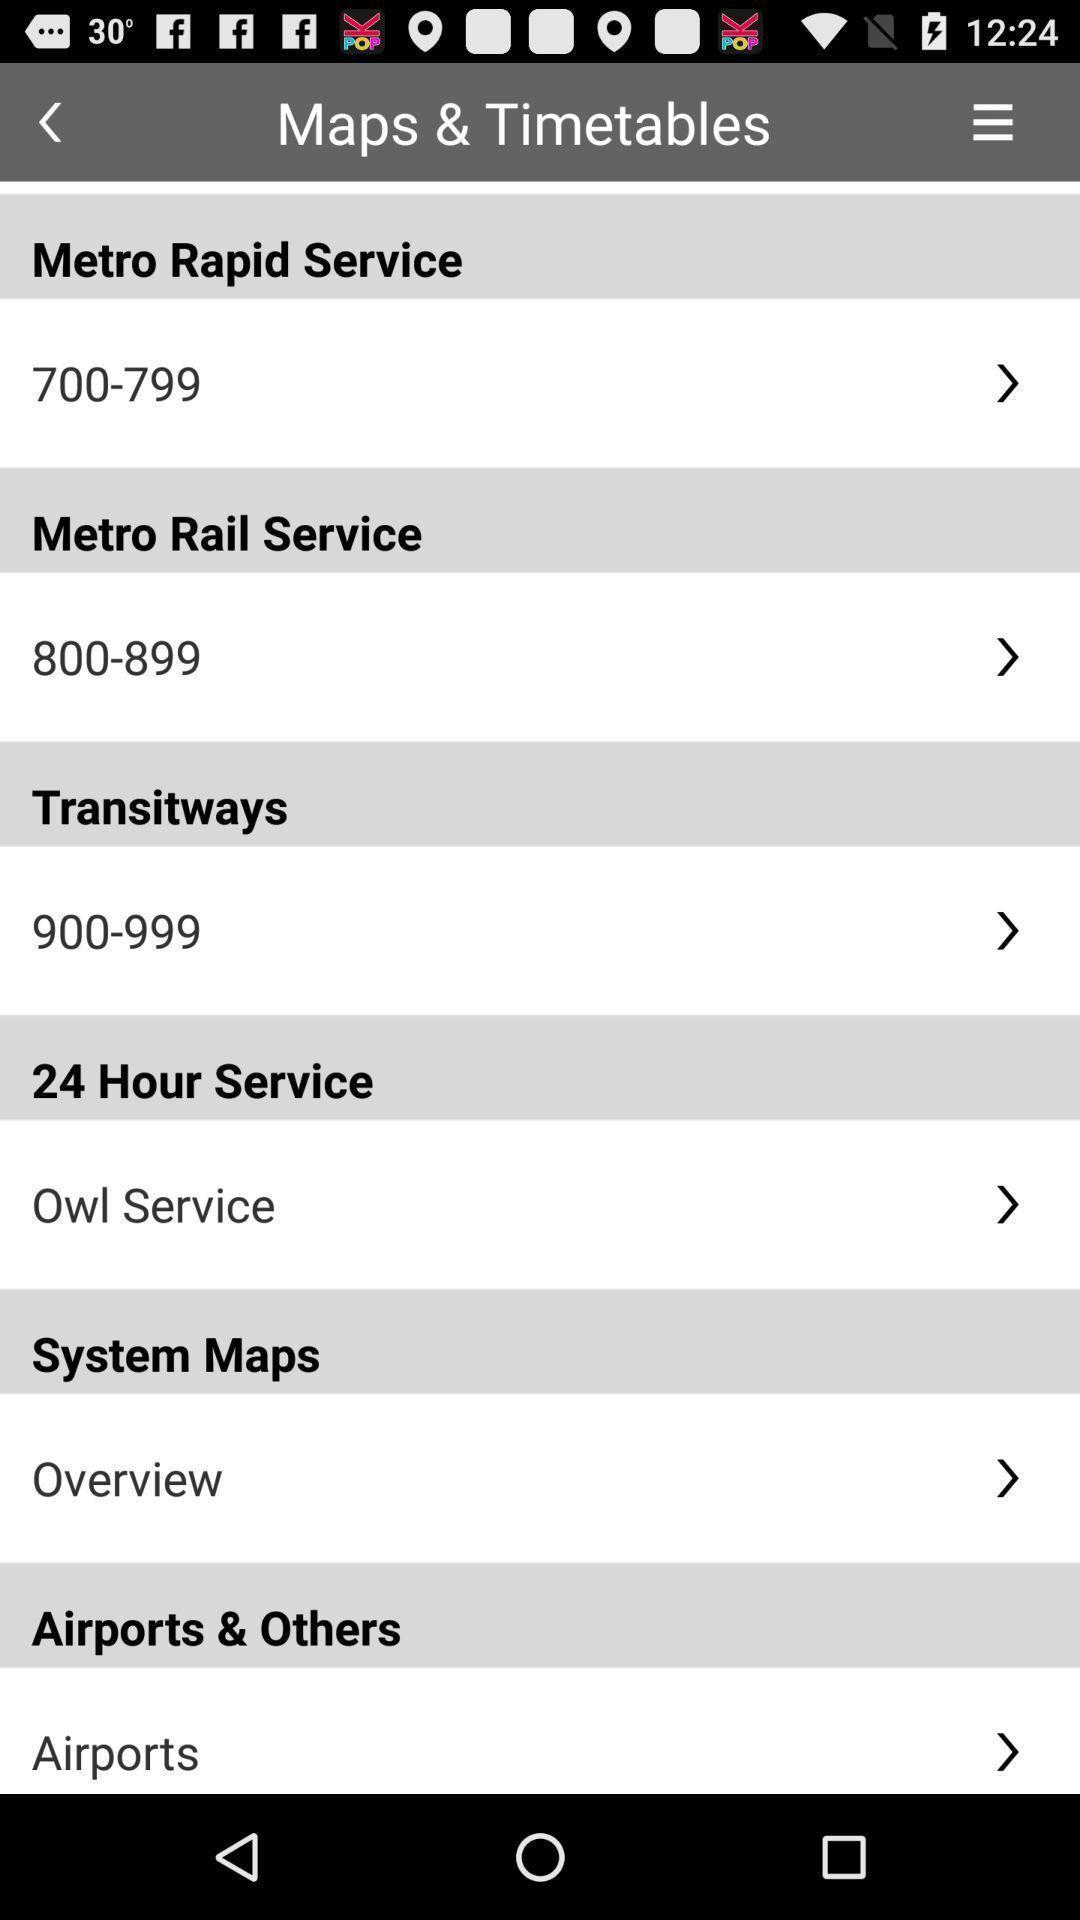Describe the content in this image. Page showing maps and timetables. 